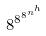Convert formula to latex. <formula><loc_0><loc_0><loc_500><loc_500>8 ^ { 8 ^ { 8 ^ { n ^ { h } } } }</formula> 